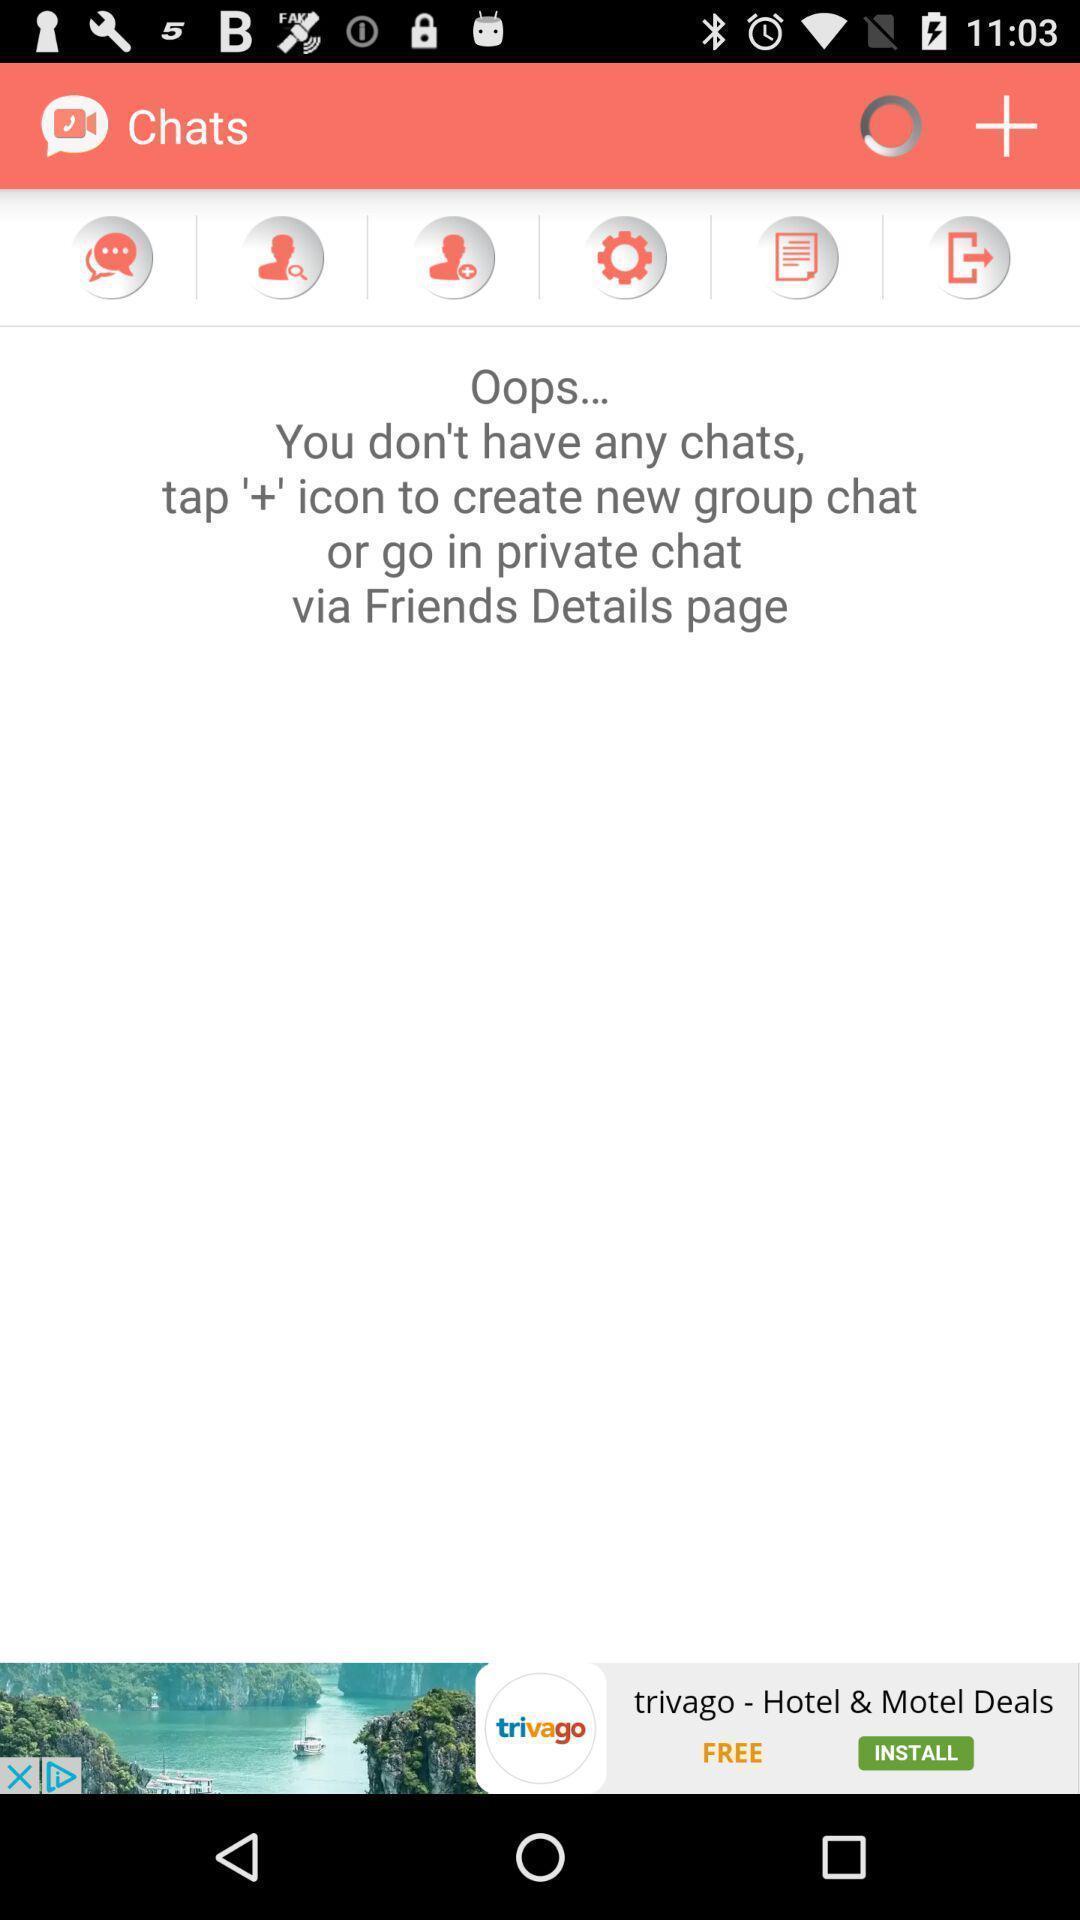What is the overall content of this screenshot? Page showing the blank list in chats. 